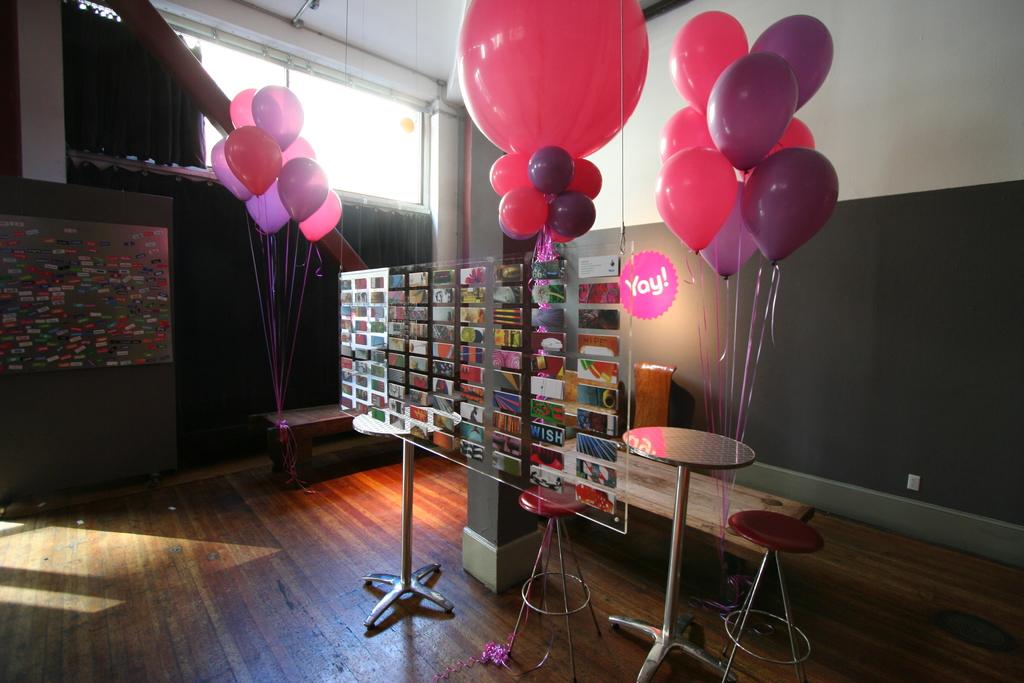Do one of the signs say "yay!"?
Your answer should be very brief. Yes. What word is seen in the second row from the right?
Give a very brief answer. Yay. 